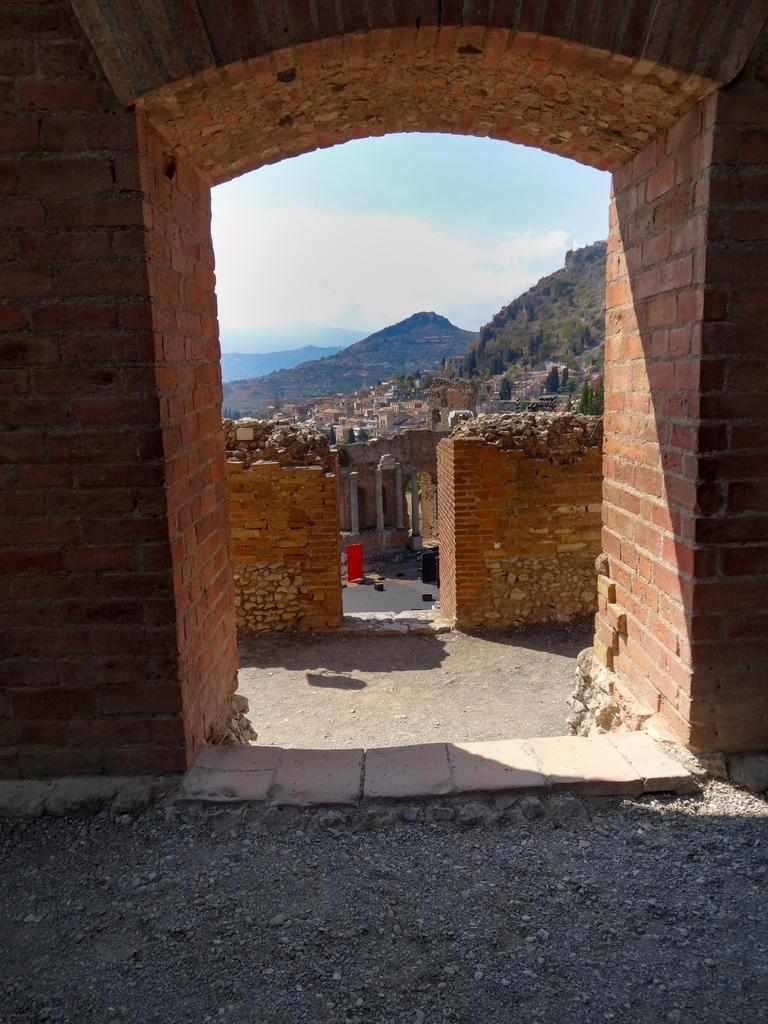What type of structure is visible in the image? There is a fort in the image. What material is used to construct the wall in the image? The wall in the image is made of bricks. What type of vegetation can be seen in the image? There are trees in the image. What type of natural landform is visible in the image? There are mountains in the image. What is the color of the sky in the image? The sky is blue and white in color. How many pies are being served at the fort in the image? There is no indication of pies being served in the image; it only shows a fort, brick wall, trees, mountains, and the sky. 